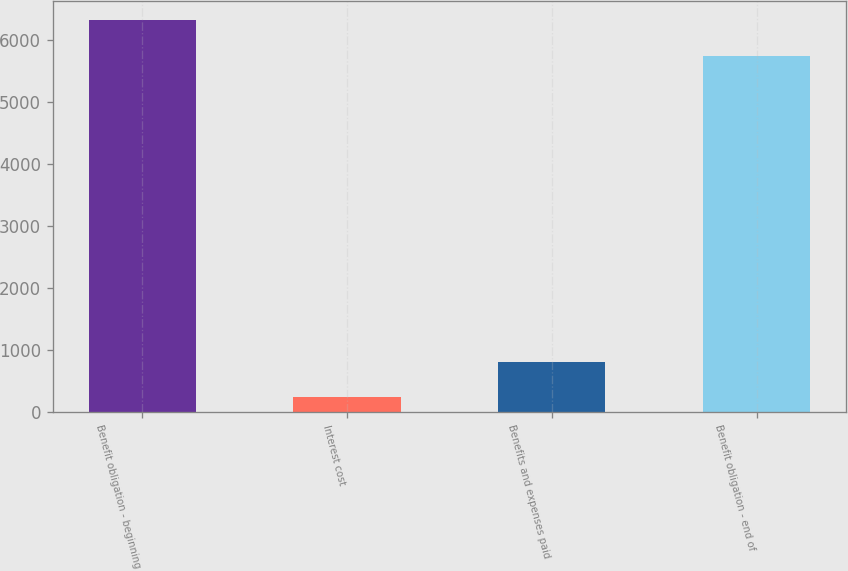Convert chart. <chart><loc_0><loc_0><loc_500><loc_500><bar_chart><fcel>Benefit obligation - beginning<fcel>Interest cost<fcel>Benefits and expenses paid<fcel>Benefit obligation - end of<nl><fcel>6313<fcel>235<fcel>814<fcel>5734<nl></chart> 